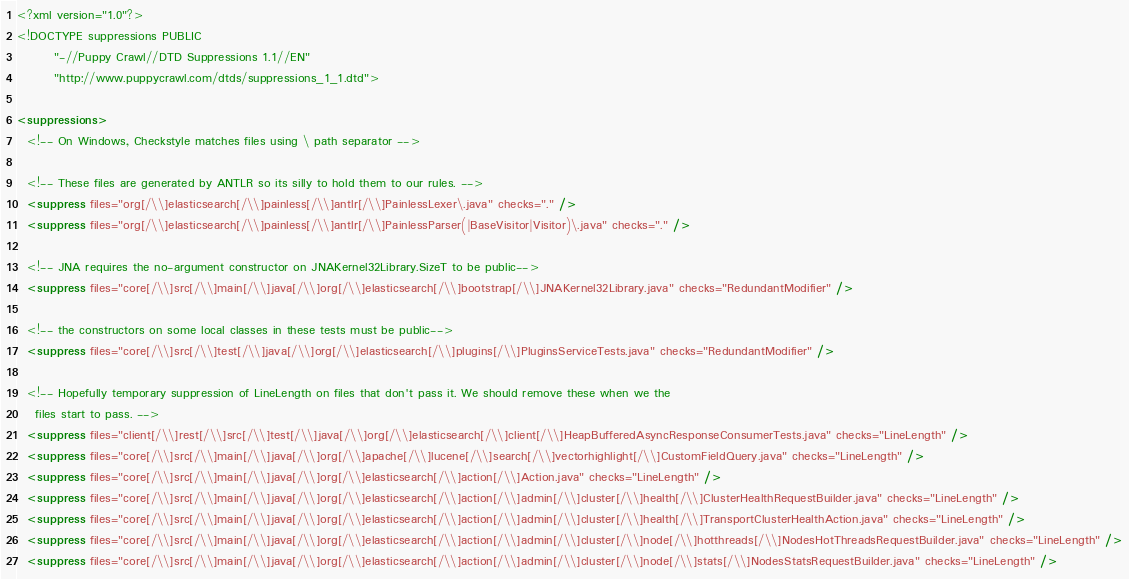Convert code to text. <code><loc_0><loc_0><loc_500><loc_500><_XML_><?xml version="1.0"?>
<!DOCTYPE suppressions PUBLIC
        "-//Puppy Crawl//DTD Suppressions 1.1//EN"
        "http://www.puppycrawl.com/dtds/suppressions_1_1.dtd">

<suppressions>
  <!-- On Windows, Checkstyle matches files using \ path separator -->

  <!-- These files are generated by ANTLR so its silly to hold them to our rules. -->
  <suppress files="org[/\\]elasticsearch[/\\]painless[/\\]antlr[/\\]PainlessLexer\.java" checks="." />
  <suppress files="org[/\\]elasticsearch[/\\]painless[/\\]antlr[/\\]PainlessParser(|BaseVisitor|Visitor)\.java" checks="." />

  <!-- JNA requires the no-argument constructor on JNAKernel32Library.SizeT to be public-->
  <suppress files="core[/\\]src[/\\]main[/\\]java[/\\]org[/\\]elasticsearch[/\\]bootstrap[/\\]JNAKernel32Library.java" checks="RedundantModifier" />

  <!-- the constructors on some local classes in these tests must be public-->
  <suppress files="core[/\\]src[/\\]test[/\\]java[/\\]org[/\\]elasticsearch[/\\]plugins[/\\]PluginsServiceTests.java" checks="RedundantModifier" />

  <!-- Hopefully temporary suppression of LineLength on files that don't pass it. We should remove these when we the
    files start to pass. -->
  <suppress files="client[/\\]rest[/\\]src[/\\]test[/\\]java[/\\]org[/\\]elasticsearch[/\\]client[/\\]HeapBufferedAsyncResponseConsumerTests.java" checks="LineLength" />
  <suppress files="core[/\\]src[/\\]main[/\\]java[/\\]org[/\\]apache[/\\]lucene[/\\]search[/\\]vectorhighlight[/\\]CustomFieldQuery.java" checks="LineLength" />
  <suppress files="core[/\\]src[/\\]main[/\\]java[/\\]org[/\\]elasticsearch[/\\]action[/\\]Action.java" checks="LineLength" />
  <suppress files="core[/\\]src[/\\]main[/\\]java[/\\]org[/\\]elasticsearch[/\\]action[/\\]admin[/\\]cluster[/\\]health[/\\]ClusterHealthRequestBuilder.java" checks="LineLength" />
  <suppress files="core[/\\]src[/\\]main[/\\]java[/\\]org[/\\]elasticsearch[/\\]action[/\\]admin[/\\]cluster[/\\]health[/\\]TransportClusterHealthAction.java" checks="LineLength" />
  <suppress files="core[/\\]src[/\\]main[/\\]java[/\\]org[/\\]elasticsearch[/\\]action[/\\]admin[/\\]cluster[/\\]node[/\\]hotthreads[/\\]NodesHotThreadsRequestBuilder.java" checks="LineLength" />
  <suppress files="core[/\\]src[/\\]main[/\\]java[/\\]org[/\\]elasticsearch[/\\]action[/\\]admin[/\\]cluster[/\\]node[/\\]stats[/\\]NodesStatsRequestBuilder.java" checks="LineLength" /></code> 